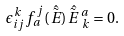Convert formula to latex. <formula><loc_0><loc_0><loc_500><loc_500>\epsilon _ { i j } ^ { \, k } f _ { a } ^ { \, j } ( \hat { \tilde { E } \, } ) \hat { \tilde { E } \, } \, ^ { a } _ { \, k } = 0 .</formula> 